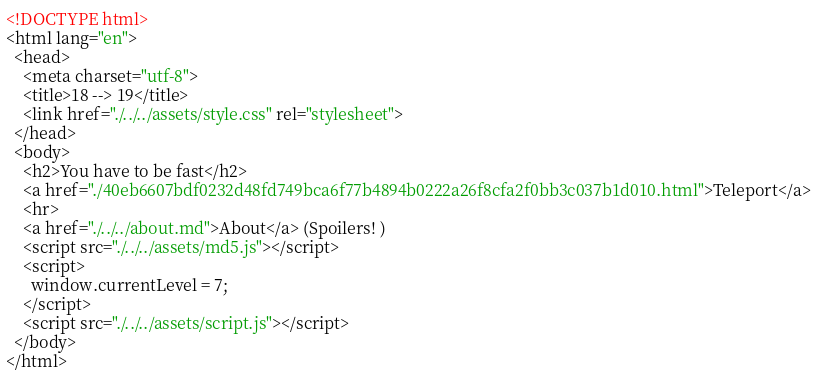<code> <loc_0><loc_0><loc_500><loc_500><_HTML_><!DOCTYPE html>
<html lang="en">
  <head>
    <meta charset="utf-8">
    <title>18 --> 19</title>
    <link href="./../../assets/style.css" rel="stylesheet">
  </head>
  <body>
    <h2>You have to be fast</h2>
    <a href="./40eb6607bdf0232d48fd749bca6f77b4894b0222a26f8cfa2f0bb3c037b1d010.html">Teleport</a>
    <hr>
    <a href="./../../about.md">About</a> (Spoilers! )
    <script src="./../../assets/md5.js"></script>
    <script>
      window.currentLevel = 7;
    </script>
    <script src="./../../assets/script.js"></script>
  </body>
</html></code> 